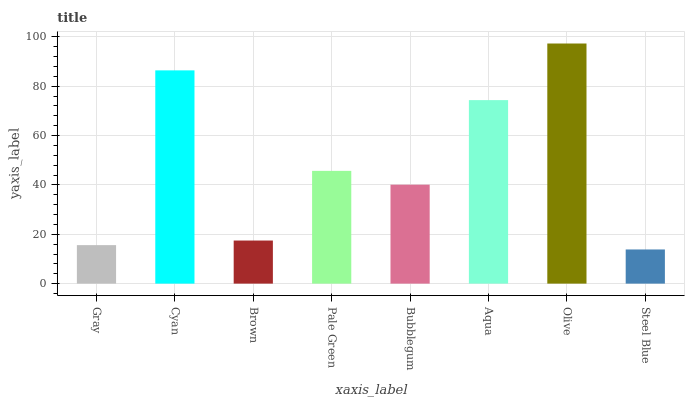Is Steel Blue the minimum?
Answer yes or no. Yes. Is Olive the maximum?
Answer yes or no. Yes. Is Cyan the minimum?
Answer yes or no. No. Is Cyan the maximum?
Answer yes or no. No. Is Cyan greater than Gray?
Answer yes or no. Yes. Is Gray less than Cyan?
Answer yes or no. Yes. Is Gray greater than Cyan?
Answer yes or no. No. Is Cyan less than Gray?
Answer yes or no. No. Is Pale Green the high median?
Answer yes or no. Yes. Is Bubblegum the low median?
Answer yes or no. Yes. Is Brown the high median?
Answer yes or no. No. Is Gray the low median?
Answer yes or no. No. 